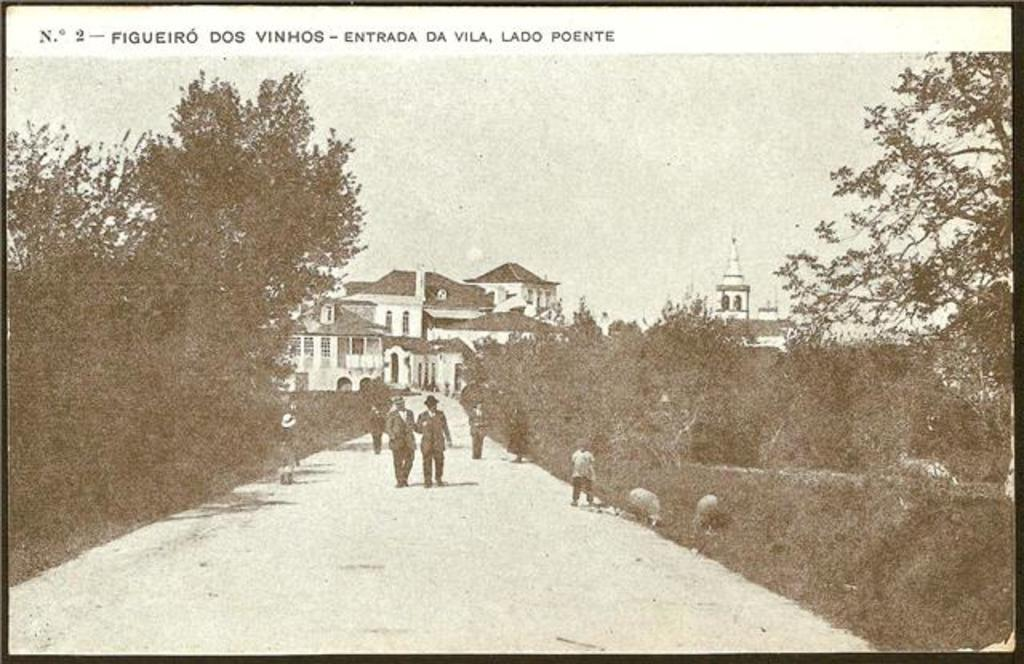What is the color scheme of the image? The image is black and white. What are the people in the image doing? The people in the image are walking on the road. What can be seen in the background of the image? There are trees and buildings visible in the background. What type of ring can be seen on the person's finger in the image? There is no ring visible on anyone's finger in the image, as it is black and white and does not show any jewelry. 